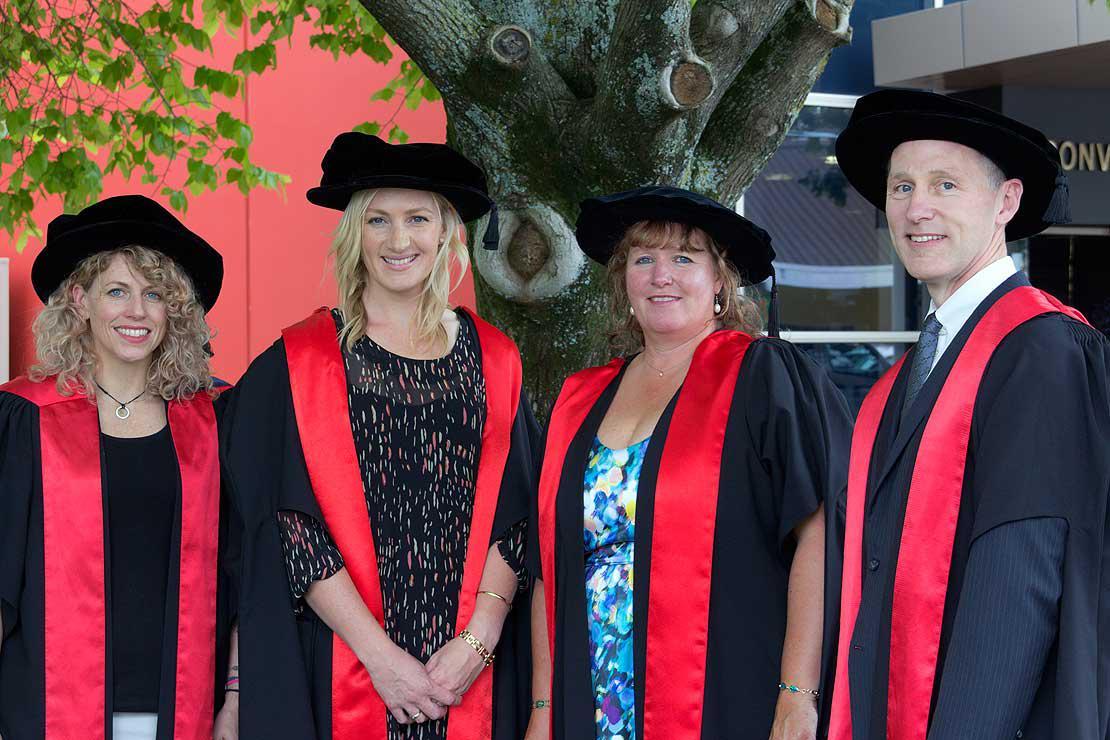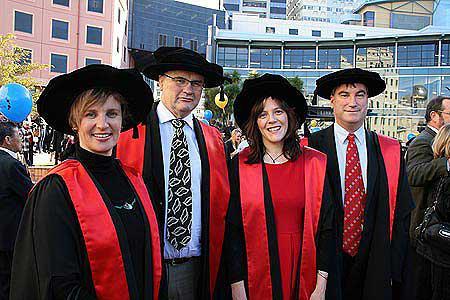The first image is the image on the left, the second image is the image on the right. Examine the images to the left and right. Is the description "At least one image includes multiple people wearing red sashes and a non-traditional graduation black cap." accurate? Answer yes or no. Yes. 